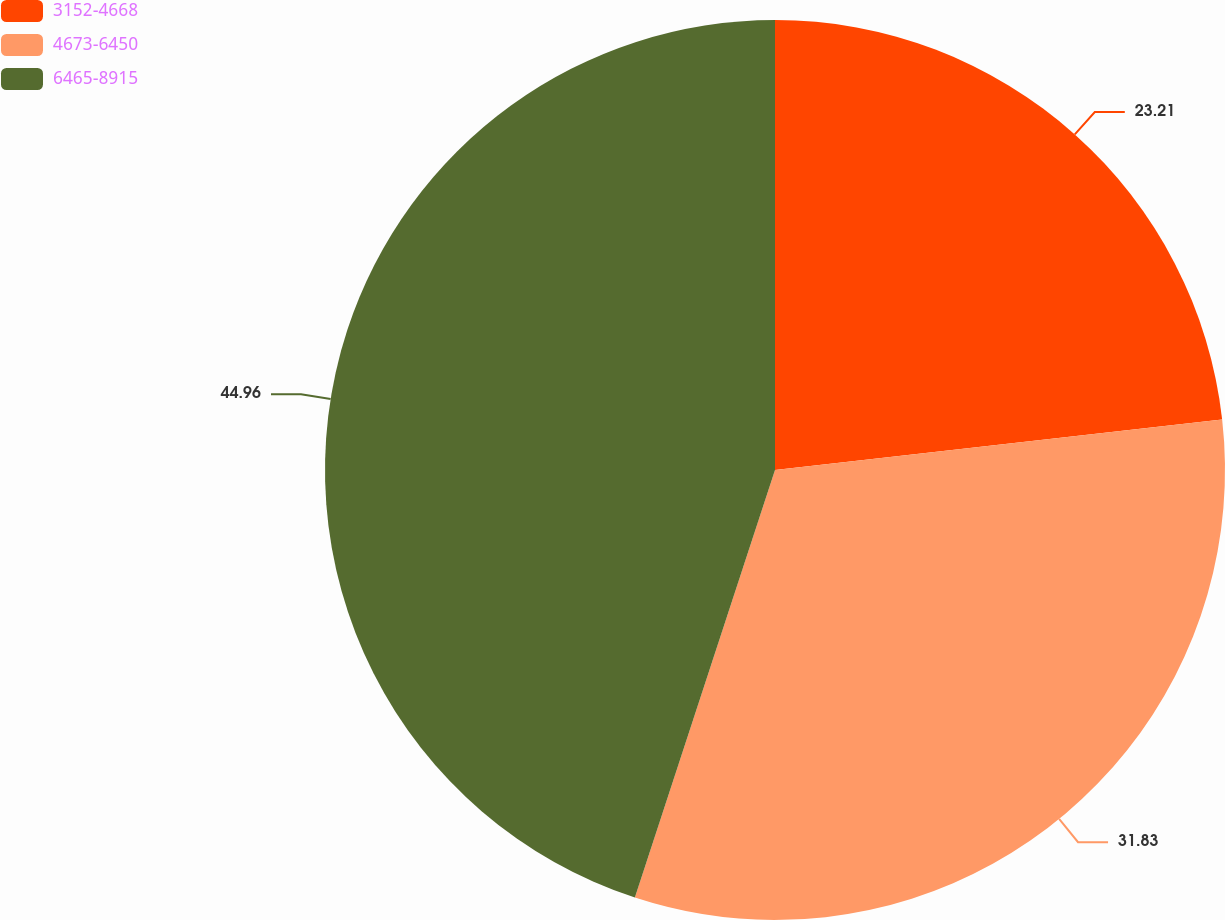<chart> <loc_0><loc_0><loc_500><loc_500><pie_chart><fcel>3152-4668<fcel>4673-6450<fcel>6465-8915<nl><fcel>23.21%<fcel>31.83%<fcel>44.96%<nl></chart> 